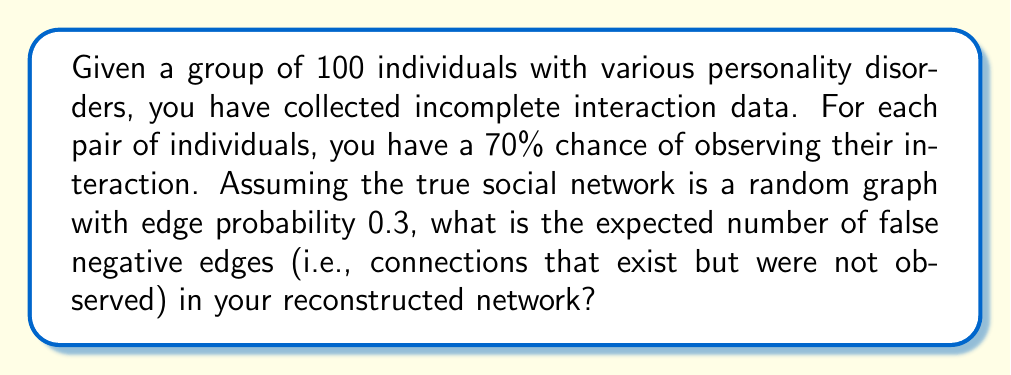Can you solve this math problem? Let's approach this step-by-step:

1) First, we need to calculate the total number of possible edges in a network of 100 individuals:
   $$\text{Total possible edges} = \binom{100}{2} = \frac{100 \times 99}{2} = 4950$$

2) The true network is a random graph with edge probability 0.3, so the expected number of true edges is:
   $$\text{Expected true edges} = 4950 \times 0.3 = 1485$$

3) For each true edge, the probability of not observing it (i.e., a false negative) is 0.3 (1 - 0.7, as we have a 70% chance of observing an interaction).

4) Therefore, the expected number of false negative edges is:
   $$\text{Expected false negatives} = 1485 \times 0.3 = 445.5$$

5) Since we're dealing with whole numbers of edges, we round this to 446.

This result represents the expected number of connections that exist in the true social network but were not captured in the observed data due to the incomplete nature of the data collection process.
Answer: 446 